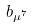Convert formula to latex. <formula><loc_0><loc_0><loc_500><loc_500>b _ { \mu ^ { 7 } }</formula> 